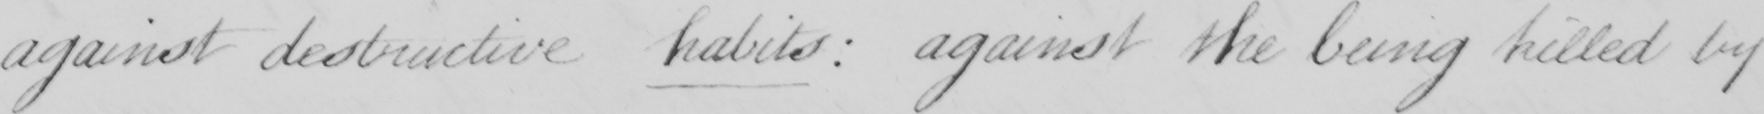Please provide the text content of this handwritten line. against destructive habits  :  against the being killed by 